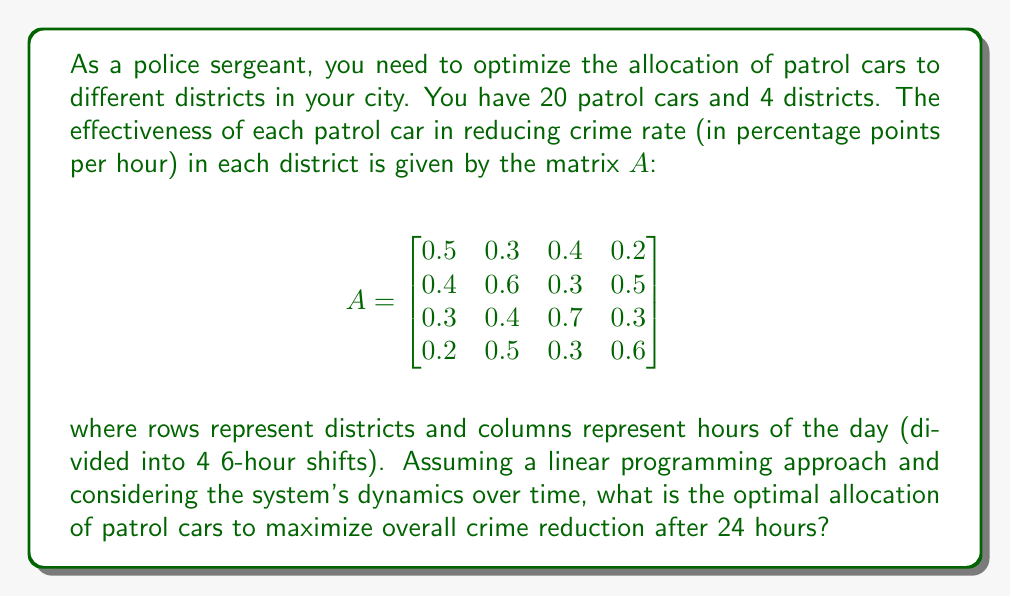Can you answer this question? To solve this problem, we'll use linear programming and consider the system's dynamics over time. Let's approach this step-by-step:

1) Define variables:
   Let $x_i$ be the number of patrol cars allocated to district $i$ (where $i = 1, 2, 3, 4$)

2) Objective function:
   We want to maximize the total crime reduction over 24 hours. This is the sum of reductions for each district over 4 shifts:
   
   $$\text{Maximize } Z = \sum_{i=1}^4 \sum_{j=1}^4 A_{ij} x_i$$

3) Constraints:
   - Total number of patrol cars: $\sum_{i=1}^4 x_i = 20$
   - Non-negativity: $x_i \geq 0$ for all $i$

4) Set up the linear program:

   $$\text{Maximize } Z = 1.4x_1 + 1.8x_2 + 1.7x_3 + 1.6x_4$$
   $$\text{Subject to: } x_1 + x_2 + x_3 + x_4 = 20$$
   $$x_1, x_2, x_3, x_4 \geq 0$$

5) Solve using the simplex method or linear programming software. The optimal solution is:

   $$x_1 = 0, x_2 = 20, x_3 = 0, x_4 = 0$$

6) Interpret the result:
   All 20 patrol cars should be allocated to district 2 to maximize overall crime reduction.

7) Calculate the total crime reduction:
   $Z = 1.8 \times 20 = 36$ percentage points over 24 hours

8) Consider system dynamics:
   The optimal allocation remains constant over the 24-hour period due to the linear nature of the model. However, in a real-world scenario, the effectiveness matrix $A$ might change over time, requiring periodic reallocation.
Answer: Allocate all 20 patrol cars to district 2, resulting in a 36 percentage point crime reduction over 24 hours. 